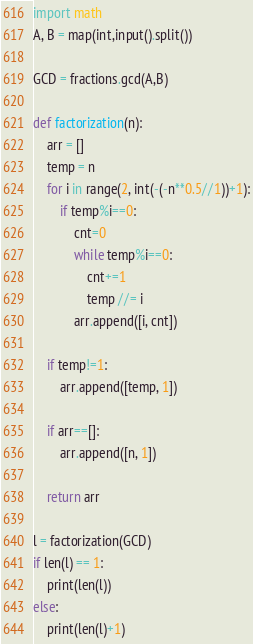Convert code to text. <code><loc_0><loc_0><loc_500><loc_500><_Python_>import math
A, B = map(int,input().split())

GCD = fractions.gcd(A,B)

def factorization(n):
    arr = []
    temp = n
    for i in range(2, int(-(-n**0.5//1))+1):
        if temp%i==0:
            cnt=0
            while temp%i==0:
                cnt+=1
                temp //= i
            arr.append([i, cnt])

    if temp!=1:
        arr.append([temp, 1])

    if arr==[]:
        arr.append([n, 1])

    return arr

l = factorization(GCD)
if len(l) == 1:
    print(len(l))
else:
    print(len(l)+1)

</code> 